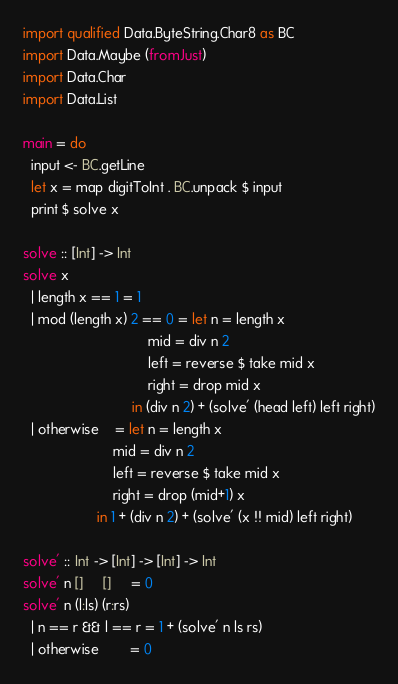<code> <loc_0><loc_0><loc_500><loc_500><_Haskell_>import qualified Data.ByteString.Char8 as BC
import Data.Maybe (fromJust)
import Data.Char
import Data.List

main = do
  input <- BC.getLine
  let x = map digitToInt . BC.unpack $ input
  print $ solve x

solve :: [Int] -> Int
solve x
  | length x == 1 = 1
  | mod (length x) 2 == 0 = let n = length x
                                mid = div n 2
                                left = reverse $ take mid x
                                right = drop mid x
                            in (div n 2) + (solve' (head left) left right)
  | otherwise    = let n = length x
                       mid = div n 2
                       left = reverse $ take mid x
                       right = drop (mid+1) x
                   in 1 + (div n 2) + (solve' (x !! mid) left right)

solve' :: Int -> [Int] -> [Int] -> Int
solve' n []     []     = 0
solve' n (l:ls) (r:rs)
  | n == r && l == r = 1 + (solve' n ls rs)
  | otherwise        = 0
</code> 